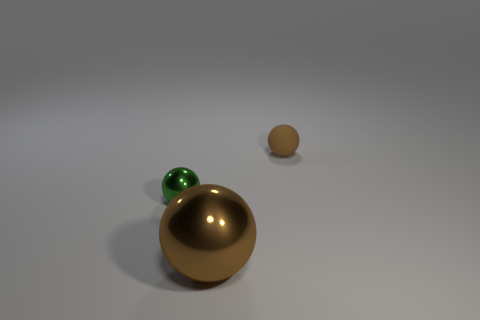Subtract all brown spheres. How many spheres are left? 1 Add 1 yellow matte objects. How many objects exist? 4 Subtract all brown spheres. How many spheres are left? 1 Subtract all brown blocks. How many green spheres are left? 1 Subtract 0 yellow balls. How many objects are left? 3 Subtract all brown balls. Subtract all purple cubes. How many balls are left? 1 Subtract all tiny blue spheres. Subtract all small metal objects. How many objects are left? 2 Add 1 balls. How many balls are left? 4 Add 1 big brown objects. How many big brown objects exist? 2 